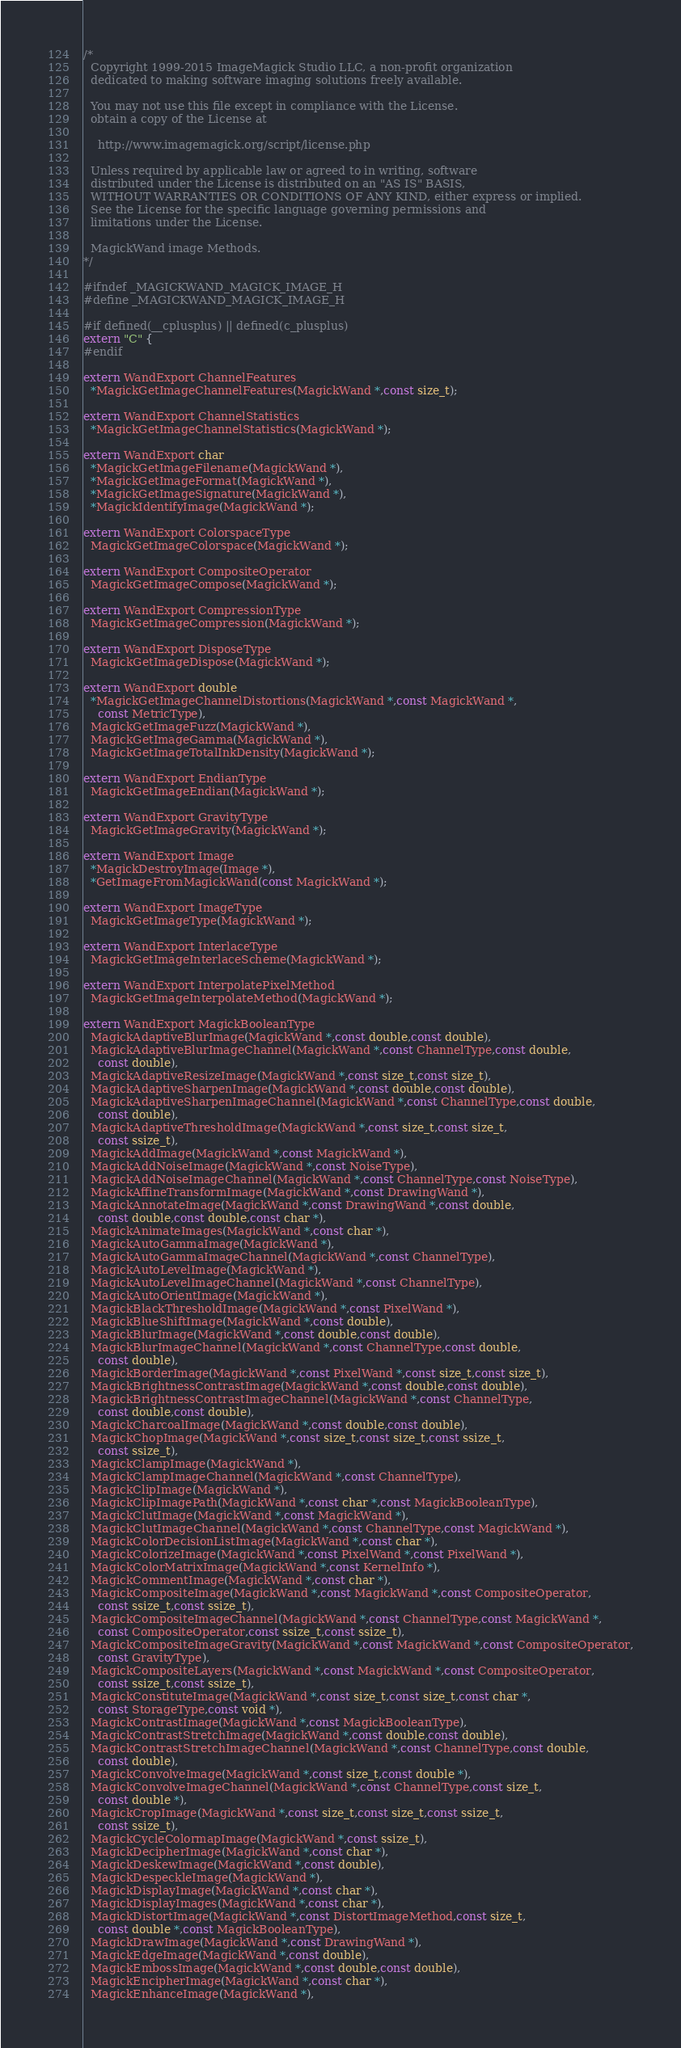<code> <loc_0><loc_0><loc_500><loc_500><_C_>/*
  Copyright 1999-2015 ImageMagick Studio LLC, a non-profit organization
  dedicated to making software imaging solutions freely available.

  You may not use this file except in compliance with the License.
  obtain a copy of the License at

    http://www.imagemagick.org/script/license.php

  Unless required by applicable law or agreed to in writing, software
  distributed under the License is distributed on an "AS IS" BASIS,
  WITHOUT WARRANTIES OR CONDITIONS OF ANY KIND, either express or implied.
  See the License for the specific language governing permissions and
  limitations under the License.

  MagickWand image Methods.
*/

#ifndef _MAGICKWAND_MAGICK_IMAGE_H
#define _MAGICKWAND_MAGICK_IMAGE_H

#if defined(__cplusplus) || defined(c_plusplus)
extern "C" {
#endif

extern WandExport ChannelFeatures
  *MagickGetImageChannelFeatures(MagickWand *,const size_t);

extern WandExport ChannelStatistics
  *MagickGetImageChannelStatistics(MagickWand *);

extern WandExport char
  *MagickGetImageFilename(MagickWand *),
  *MagickGetImageFormat(MagickWand *),
  *MagickGetImageSignature(MagickWand *),
  *MagickIdentifyImage(MagickWand *);

extern WandExport ColorspaceType
  MagickGetImageColorspace(MagickWand *);

extern WandExport CompositeOperator
  MagickGetImageCompose(MagickWand *);

extern WandExport CompressionType
  MagickGetImageCompression(MagickWand *);

extern WandExport DisposeType
  MagickGetImageDispose(MagickWand *);

extern WandExport double
  *MagickGetImageChannelDistortions(MagickWand *,const MagickWand *,
    const MetricType),
  MagickGetImageFuzz(MagickWand *),
  MagickGetImageGamma(MagickWand *),
  MagickGetImageTotalInkDensity(MagickWand *);

extern WandExport EndianType
  MagickGetImageEndian(MagickWand *);

extern WandExport GravityType
  MagickGetImageGravity(MagickWand *);

extern WandExport Image
  *MagickDestroyImage(Image *),
  *GetImageFromMagickWand(const MagickWand *);

extern WandExport ImageType
  MagickGetImageType(MagickWand *);

extern WandExport InterlaceType
  MagickGetImageInterlaceScheme(MagickWand *);

extern WandExport InterpolatePixelMethod
  MagickGetImageInterpolateMethod(MagickWand *);

extern WandExport MagickBooleanType
  MagickAdaptiveBlurImage(MagickWand *,const double,const double),
  MagickAdaptiveBlurImageChannel(MagickWand *,const ChannelType,const double,
    const double),
  MagickAdaptiveResizeImage(MagickWand *,const size_t,const size_t),
  MagickAdaptiveSharpenImage(MagickWand *,const double,const double),
  MagickAdaptiveSharpenImageChannel(MagickWand *,const ChannelType,const double,
    const double),
  MagickAdaptiveThresholdImage(MagickWand *,const size_t,const size_t,
    const ssize_t),
  MagickAddImage(MagickWand *,const MagickWand *),
  MagickAddNoiseImage(MagickWand *,const NoiseType),
  MagickAddNoiseImageChannel(MagickWand *,const ChannelType,const NoiseType),
  MagickAffineTransformImage(MagickWand *,const DrawingWand *),
  MagickAnnotateImage(MagickWand *,const DrawingWand *,const double,
    const double,const double,const char *),
  MagickAnimateImages(MagickWand *,const char *),
  MagickAutoGammaImage(MagickWand *),
  MagickAutoGammaImageChannel(MagickWand *,const ChannelType),
  MagickAutoLevelImage(MagickWand *),
  MagickAutoLevelImageChannel(MagickWand *,const ChannelType),
  MagickAutoOrientImage(MagickWand *),
  MagickBlackThresholdImage(MagickWand *,const PixelWand *),
  MagickBlueShiftImage(MagickWand *,const double),
  MagickBlurImage(MagickWand *,const double,const double),
  MagickBlurImageChannel(MagickWand *,const ChannelType,const double,
    const double),
  MagickBorderImage(MagickWand *,const PixelWand *,const size_t,const size_t),
  MagickBrightnessContrastImage(MagickWand *,const double,const double),
  MagickBrightnessContrastImageChannel(MagickWand *,const ChannelType,
    const double,const double),
  MagickCharcoalImage(MagickWand *,const double,const double),
  MagickChopImage(MagickWand *,const size_t,const size_t,const ssize_t,
    const ssize_t),
  MagickClampImage(MagickWand *),
  MagickClampImageChannel(MagickWand *,const ChannelType),
  MagickClipImage(MagickWand *),
  MagickClipImagePath(MagickWand *,const char *,const MagickBooleanType),
  MagickClutImage(MagickWand *,const MagickWand *),
  MagickClutImageChannel(MagickWand *,const ChannelType,const MagickWand *),
  MagickColorDecisionListImage(MagickWand *,const char *),
  MagickColorizeImage(MagickWand *,const PixelWand *,const PixelWand *),
  MagickColorMatrixImage(MagickWand *,const KernelInfo *),
  MagickCommentImage(MagickWand *,const char *),
  MagickCompositeImage(MagickWand *,const MagickWand *,const CompositeOperator,
    const ssize_t,const ssize_t),
  MagickCompositeImageChannel(MagickWand *,const ChannelType,const MagickWand *,
    const CompositeOperator,const ssize_t,const ssize_t),
  MagickCompositeImageGravity(MagickWand *,const MagickWand *,const CompositeOperator,
    const GravityType),
  MagickCompositeLayers(MagickWand *,const MagickWand *,const CompositeOperator,
    const ssize_t,const ssize_t),
  MagickConstituteImage(MagickWand *,const size_t,const size_t,const char *,
    const StorageType,const void *),
  MagickContrastImage(MagickWand *,const MagickBooleanType),
  MagickContrastStretchImage(MagickWand *,const double,const double),
  MagickContrastStretchImageChannel(MagickWand *,const ChannelType,const double,
    const double),
  MagickConvolveImage(MagickWand *,const size_t,const double *),
  MagickConvolveImageChannel(MagickWand *,const ChannelType,const size_t,
    const double *),
  MagickCropImage(MagickWand *,const size_t,const size_t,const ssize_t,
    const ssize_t),
  MagickCycleColormapImage(MagickWand *,const ssize_t),
  MagickDecipherImage(MagickWand *,const char *),
  MagickDeskewImage(MagickWand *,const double),
  MagickDespeckleImage(MagickWand *),
  MagickDisplayImage(MagickWand *,const char *),
  MagickDisplayImages(MagickWand *,const char *),
  MagickDistortImage(MagickWand *,const DistortImageMethod,const size_t,
    const double *,const MagickBooleanType),
  MagickDrawImage(MagickWand *,const DrawingWand *),
  MagickEdgeImage(MagickWand *,const double),
  MagickEmbossImage(MagickWand *,const double,const double),
  MagickEncipherImage(MagickWand *,const char *),
  MagickEnhanceImage(MagickWand *),</code> 